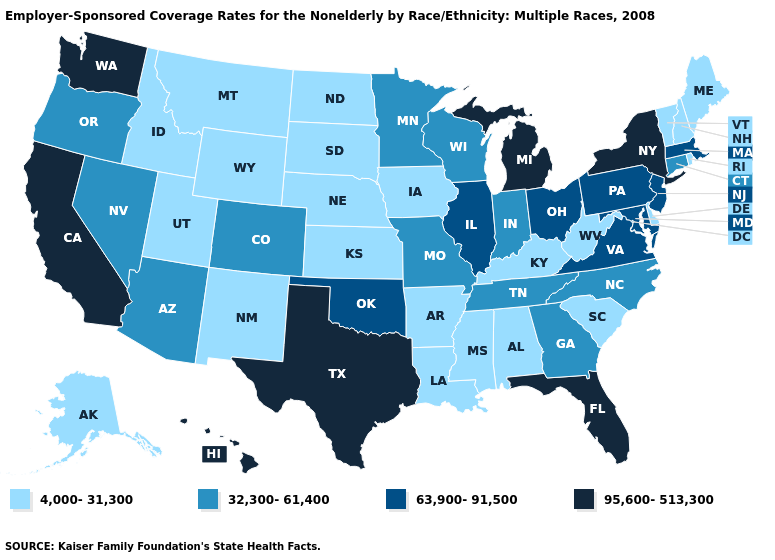How many symbols are there in the legend?
Short answer required. 4. Name the states that have a value in the range 4,000-31,300?
Short answer required. Alabama, Alaska, Arkansas, Delaware, Idaho, Iowa, Kansas, Kentucky, Louisiana, Maine, Mississippi, Montana, Nebraska, New Hampshire, New Mexico, North Dakota, Rhode Island, South Carolina, South Dakota, Utah, Vermont, West Virginia, Wyoming. Which states have the lowest value in the USA?
Answer briefly. Alabama, Alaska, Arkansas, Delaware, Idaho, Iowa, Kansas, Kentucky, Louisiana, Maine, Mississippi, Montana, Nebraska, New Hampshire, New Mexico, North Dakota, Rhode Island, South Carolina, South Dakota, Utah, Vermont, West Virginia, Wyoming. Does Arkansas have a lower value than Vermont?
Give a very brief answer. No. What is the highest value in the South ?
Write a very short answer. 95,600-513,300. Among the states that border Wyoming , which have the highest value?
Keep it brief. Colorado. Name the states that have a value in the range 32,300-61,400?
Answer briefly. Arizona, Colorado, Connecticut, Georgia, Indiana, Minnesota, Missouri, Nevada, North Carolina, Oregon, Tennessee, Wisconsin. Does Virginia have the lowest value in the South?
Quick response, please. No. Is the legend a continuous bar?
Short answer required. No. Name the states that have a value in the range 4,000-31,300?
Write a very short answer. Alabama, Alaska, Arkansas, Delaware, Idaho, Iowa, Kansas, Kentucky, Louisiana, Maine, Mississippi, Montana, Nebraska, New Hampshire, New Mexico, North Dakota, Rhode Island, South Carolina, South Dakota, Utah, Vermont, West Virginia, Wyoming. What is the value of Idaho?
Answer briefly. 4,000-31,300. What is the value of Minnesota?
Answer briefly. 32,300-61,400. Name the states that have a value in the range 4,000-31,300?
Keep it brief. Alabama, Alaska, Arkansas, Delaware, Idaho, Iowa, Kansas, Kentucky, Louisiana, Maine, Mississippi, Montana, Nebraska, New Hampshire, New Mexico, North Dakota, Rhode Island, South Carolina, South Dakota, Utah, Vermont, West Virginia, Wyoming. What is the highest value in states that border Kentucky?
Write a very short answer. 63,900-91,500. What is the value of Ohio?
Give a very brief answer. 63,900-91,500. 